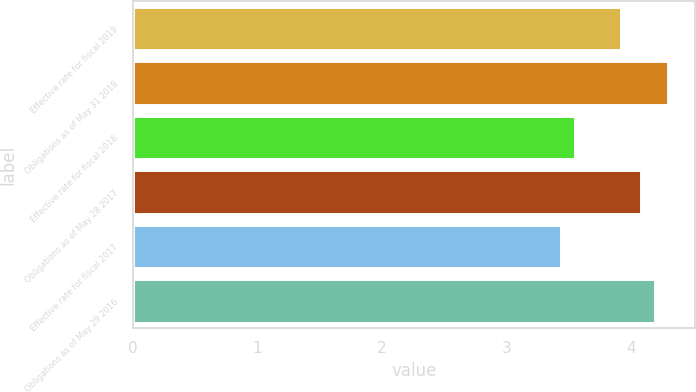Convert chart to OTSL. <chart><loc_0><loc_0><loc_500><loc_500><bar_chart><fcel>Effective rate for fiscal 2019<fcel>Obligations as of May 31 2018<fcel>Effective rate for fiscal 2018<fcel>Obligations as of May 28 2017<fcel>Effective rate for fiscal 2017<fcel>Obligations as of May 29 2016<nl><fcel>3.92<fcel>4.3<fcel>3.55<fcel>4.08<fcel>3.44<fcel>4.19<nl></chart> 